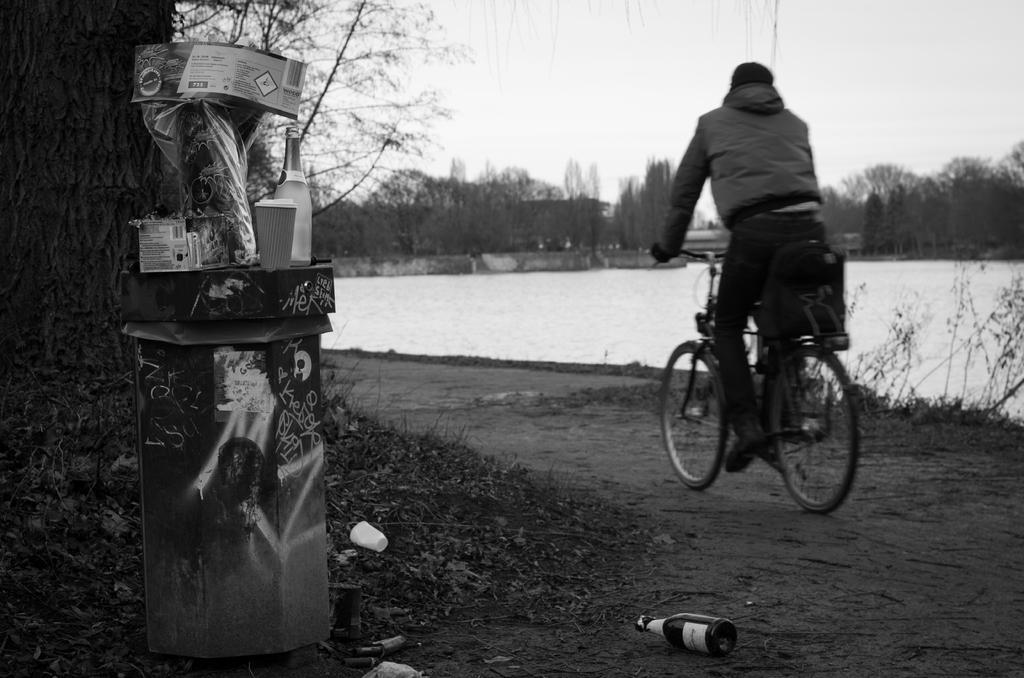Could you give a brief overview of what you see in this image? This is a black and white picture. It is taken in the outdoor. A man is riding his bicycle on the path and on the path there are cups, bottle and some items. In front of the man there is a water, trees and sky. 